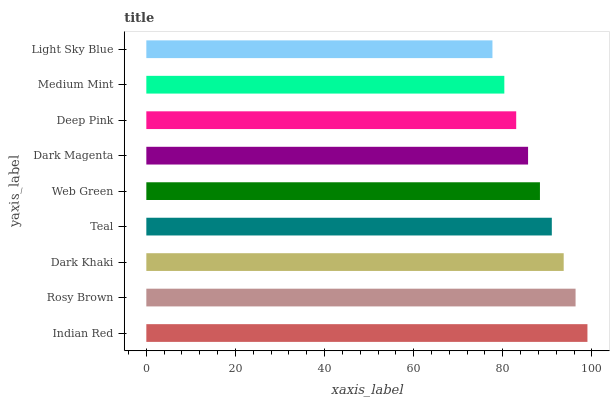Is Light Sky Blue the minimum?
Answer yes or no. Yes. Is Indian Red the maximum?
Answer yes or no. Yes. Is Rosy Brown the minimum?
Answer yes or no. No. Is Rosy Brown the maximum?
Answer yes or no. No. Is Indian Red greater than Rosy Brown?
Answer yes or no. Yes. Is Rosy Brown less than Indian Red?
Answer yes or no. Yes. Is Rosy Brown greater than Indian Red?
Answer yes or no. No. Is Indian Red less than Rosy Brown?
Answer yes or no. No. Is Web Green the high median?
Answer yes or no. Yes. Is Web Green the low median?
Answer yes or no. Yes. Is Deep Pink the high median?
Answer yes or no. No. Is Dark Magenta the low median?
Answer yes or no. No. 